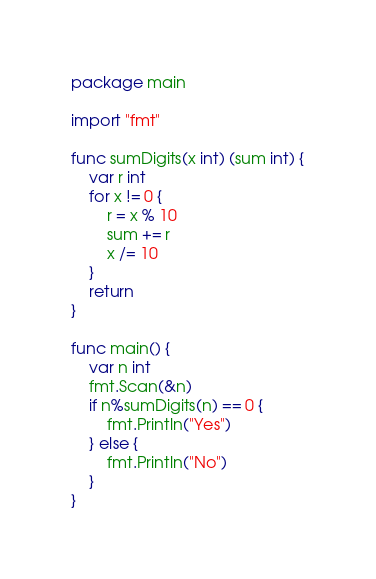Convert code to text. <code><loc_0><loc_0><loc_500><loc_500><_Go_>package main

import "fmt"

func sumDigits(x int) (sum int) {
	var r int
	for x != 0 {
		r = x % 10
		sum += r
		x /= 10
	}
	return
}

func main() {
	var n int
	fmt.Scan(&n)
	if n%sumDigits(n) == 0 {
		fmt.Println("Yes")
	} else {
		fmt.Println("No")
	}
}
</code> 